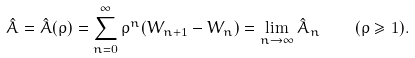<formula> <loc_0><loc_0><loc_500><loc_500>\hat { A } = \hat { A } ( \rho ) = \sum _ { n = 0 } ^ { \infty } \rho ^ { n } ( W _ { n + 1 } - W _ { n } ) = \lim _ { n \rightarrow \infty } \hat { A } _ { n } \quad ( \rho \geq 1 ) .</formula> 